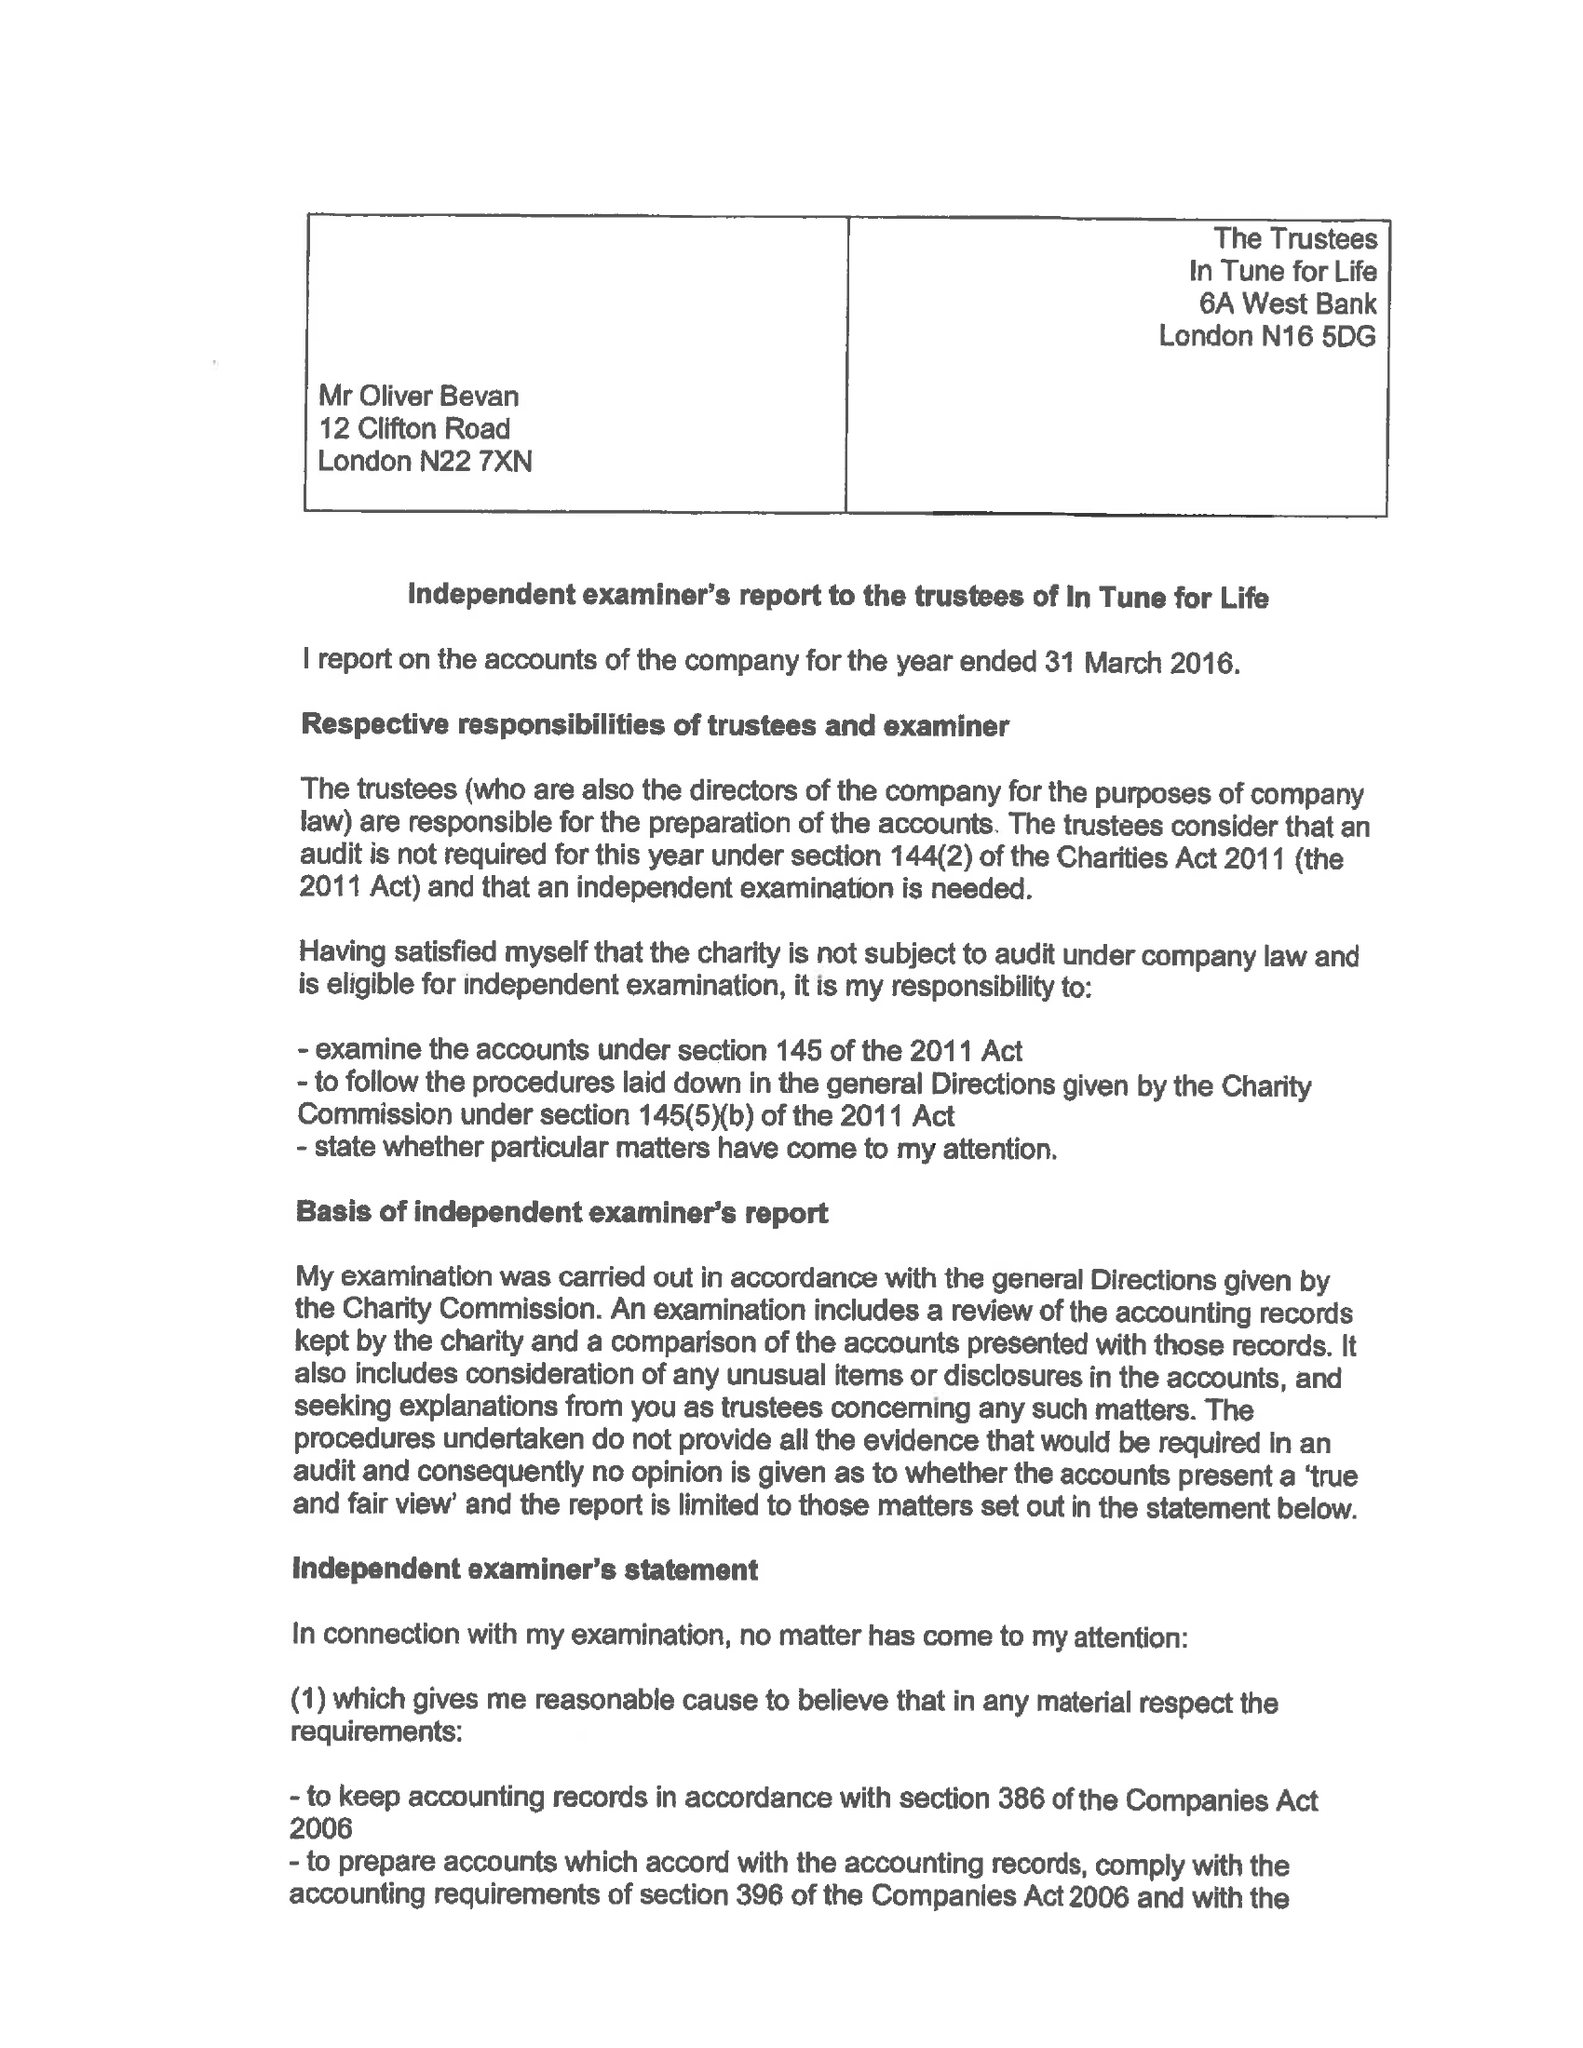What is the value for the address__postcode?
Answer the question using a single word or phrase. PO7 8RX 